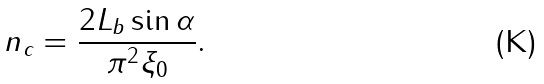Convert formula to latex. <formula><loc_0><loc_0><loc_500><loc_500>n _ { c } = \frac { 2 L _ { b } \sin \alpha } { \pi ^ { 2 } \xi _ { 0 } } .</formula> 